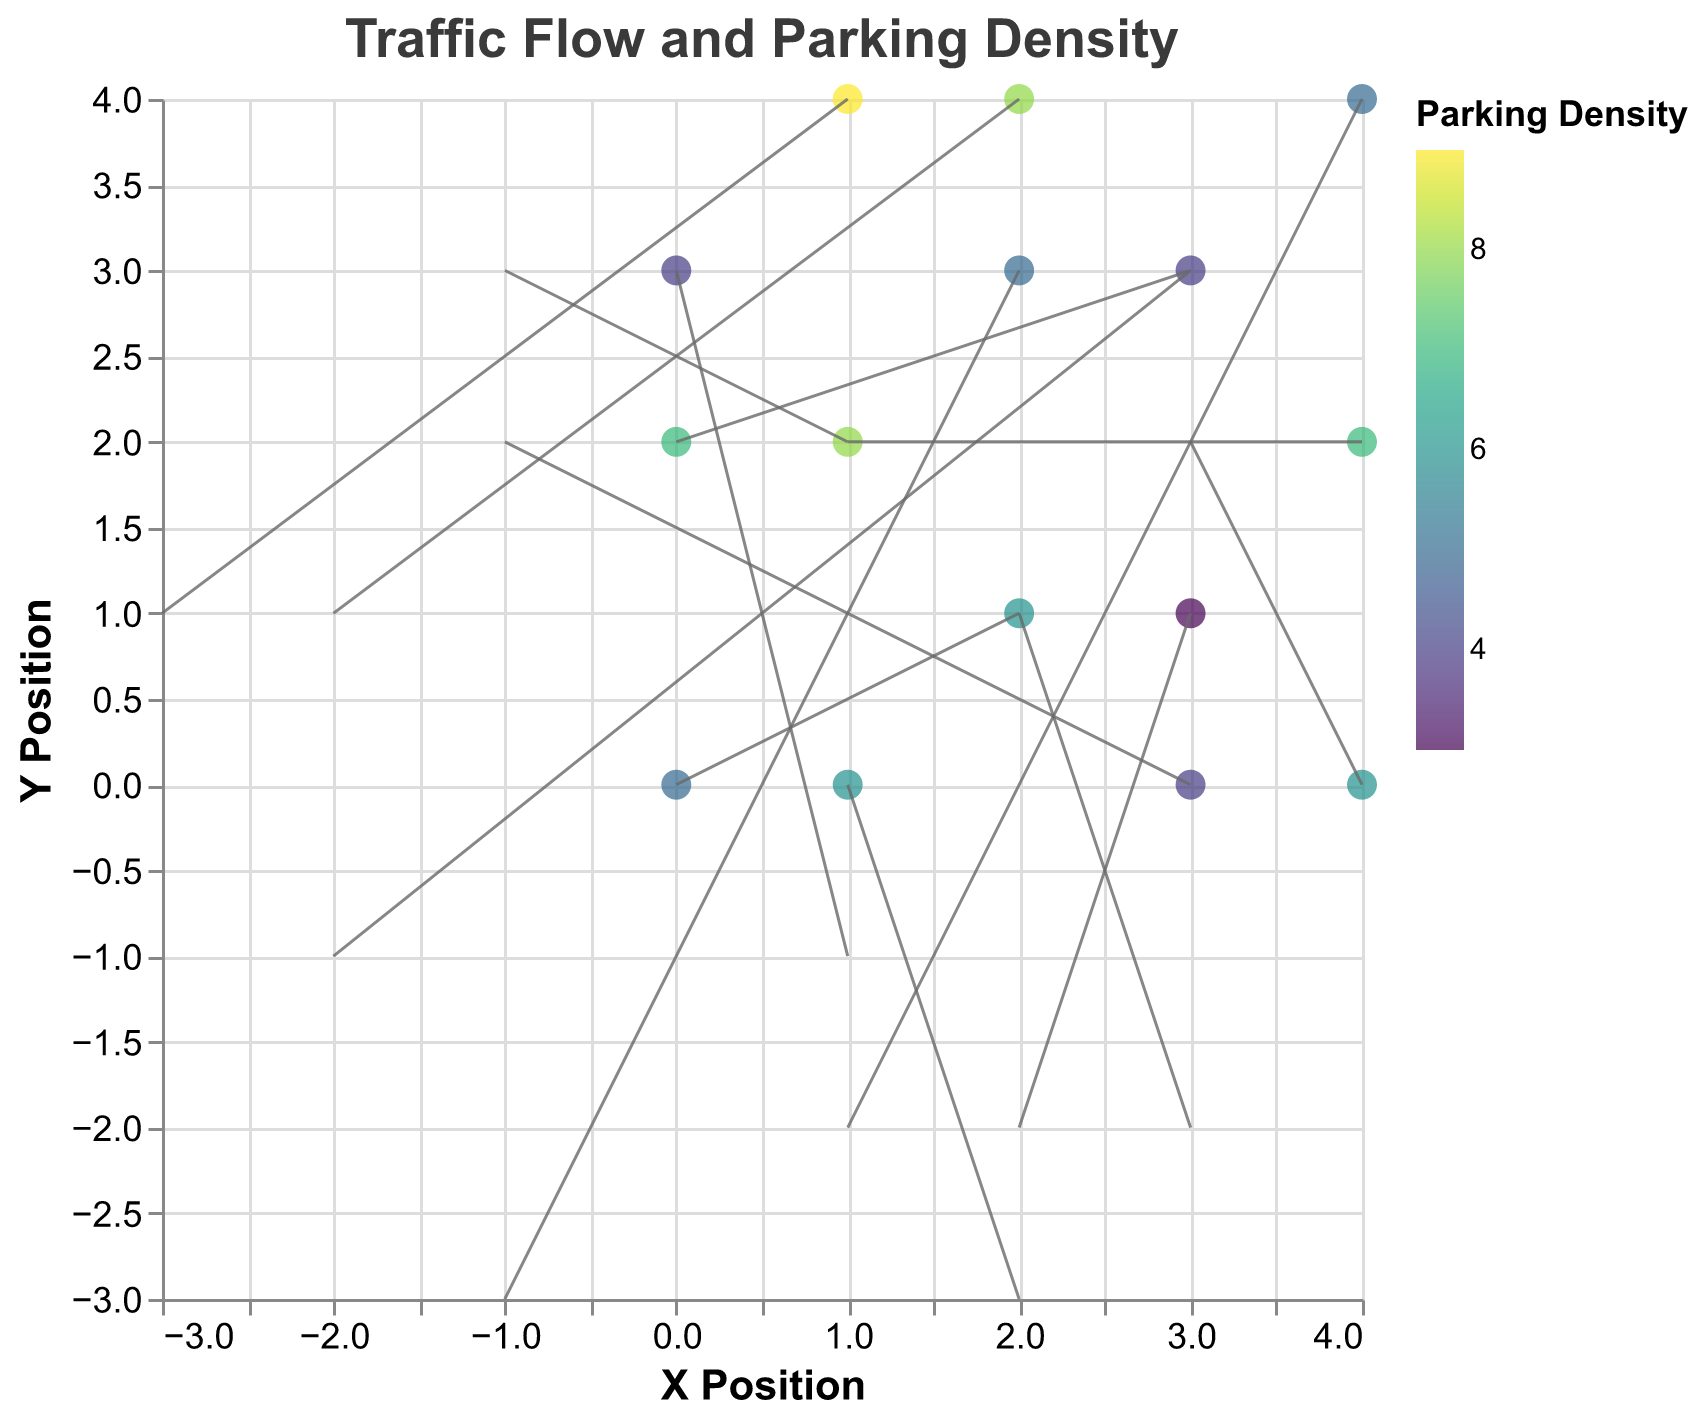What is the title of the figure? The title of a figure is usually the text displayed at the top, in this case, it read: "Traffic Flow and Parking Density"
Answer: Traffic Flow and Parking Density What are the labels of the X and Y axes? The labels of the axes are written near the respective axes, and here they are labeled "X Position" and "Y Position"
Answer: X Position, Y Position What does the color of the points represent? The color of the points is usually indicated by the legend, which here shows that it represents "Parking Density"
Answer: Parking Density How many data points are displayed in the plot? Counting all the distinct points provided in the data will give us the total number, which is 15
Answer: 15 Which data point has the highest parking density? From the color scale or the tooltip information, the point (1, 4) has the highest density which is 9
Answer: (1, 4) In which direction is the traffic flow at position (4, 0)? The flow direction is indicated by the arrow direction and the u, v values. Here, u=3 and v=2 means traffic moves to the right and slightly up
Answer: Right and up What is the average parking density value of all the data points? Sum the density values of all points and divide by the number of points: (5+8+6+4+7+9+3+5+6+4+8+5+7+4+6)/15 = 87/15 = 5.8
Answer: 5.8 Comparing points (0, 0) and (1, 2), which one has a higher density? Check and compare the density values. Point (1, 2) has a density of 8, which is higher than the density of 5 at point (0, 0)
Answer: (1, 2) Which point has the largest traffic vector magnitude? Magnitude is calculated as sqrt(u^2 + v^2). The point (0, 2) has vector u=3 and v=3, giving magnitude sqrt(3^2 + 3^2) = sqrt(18) = 4.24, which is the largest.
Answer: (0, 2) Where does traffic move almost vertically? Traffic aligns vertically if one component (either u or v) is close to zero. At (2, 3) u=-1⋁v=-3, the u component is small and traffic moves almost straight down.
Answer: (2, 3) 